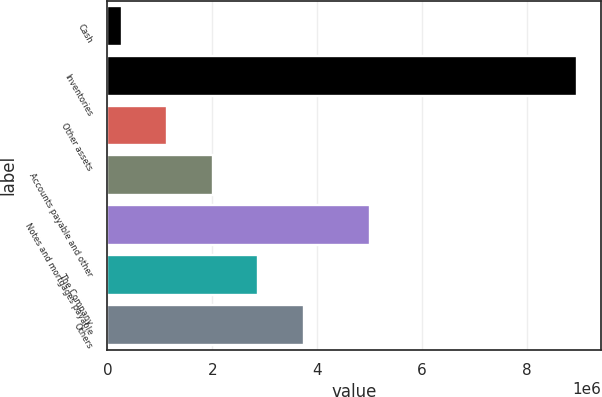Convert chart. <chart><loc_0><loc_0><loc_500><loc_500><bar_chart><fcel>Cash<fcel>Inventories<fcel>Other assets<fcel>Accounts payable and other<fcel>Notes and mortgages payable<fcel>The Company<fcel>Others<nl><fcel>276501<fcel>8.95557e+06<fcel>1.14441e+06<fcel>2.01231e+06<fcel>5.00162e+06<fcel>2.88022e+06<fcel>3.74813e+06<nl></chart> 